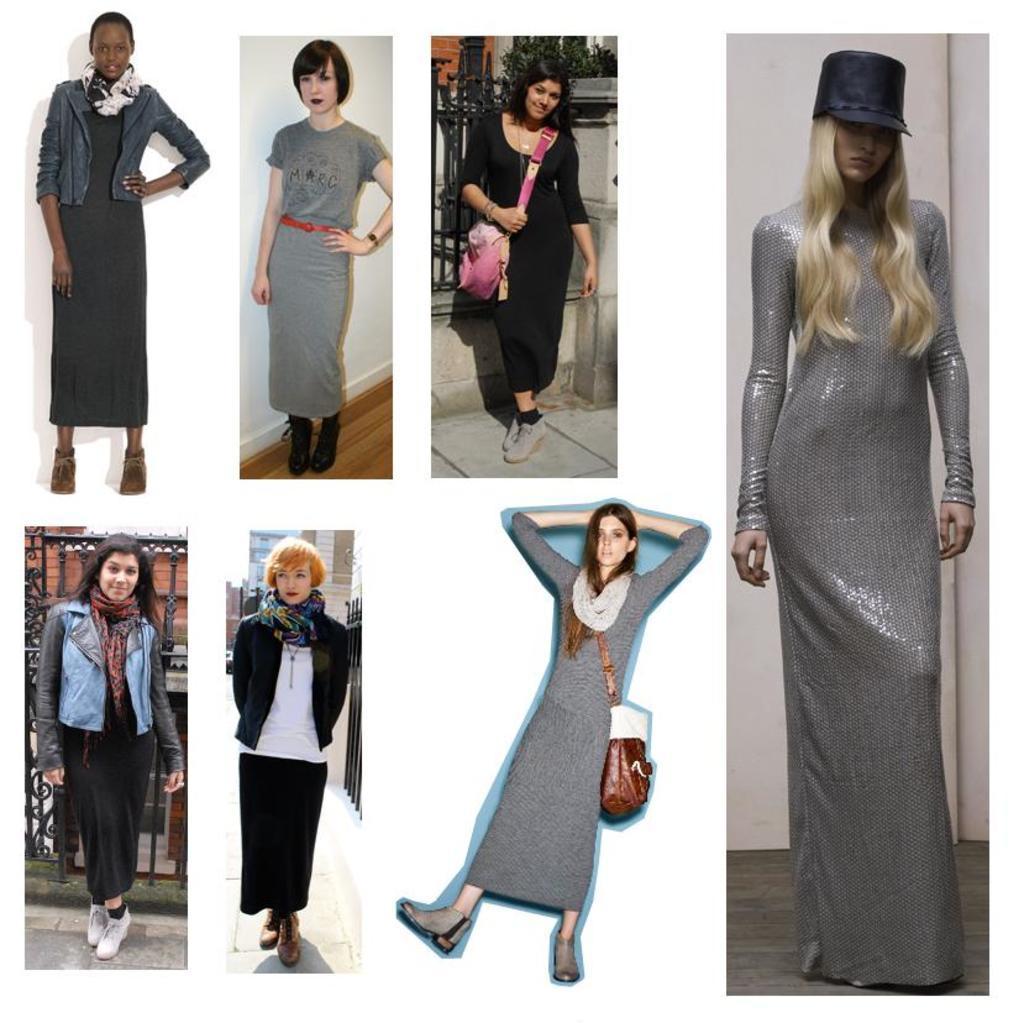Please provide a concise description of this image. In this picture I can see the collage image, in which I see few women who are standing. 